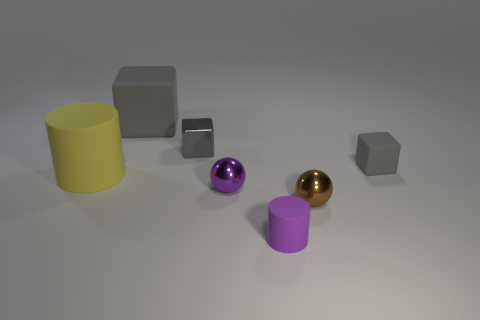What can you infer about the lighting in this scene? The lighting in the scene appears to be diffused, with soft shadows indicating either a single light source or a softbox has been used. The lack of sharp, dark shadows suggests that the light is not overly harsh, providing even illumination to the objects in the scene. 